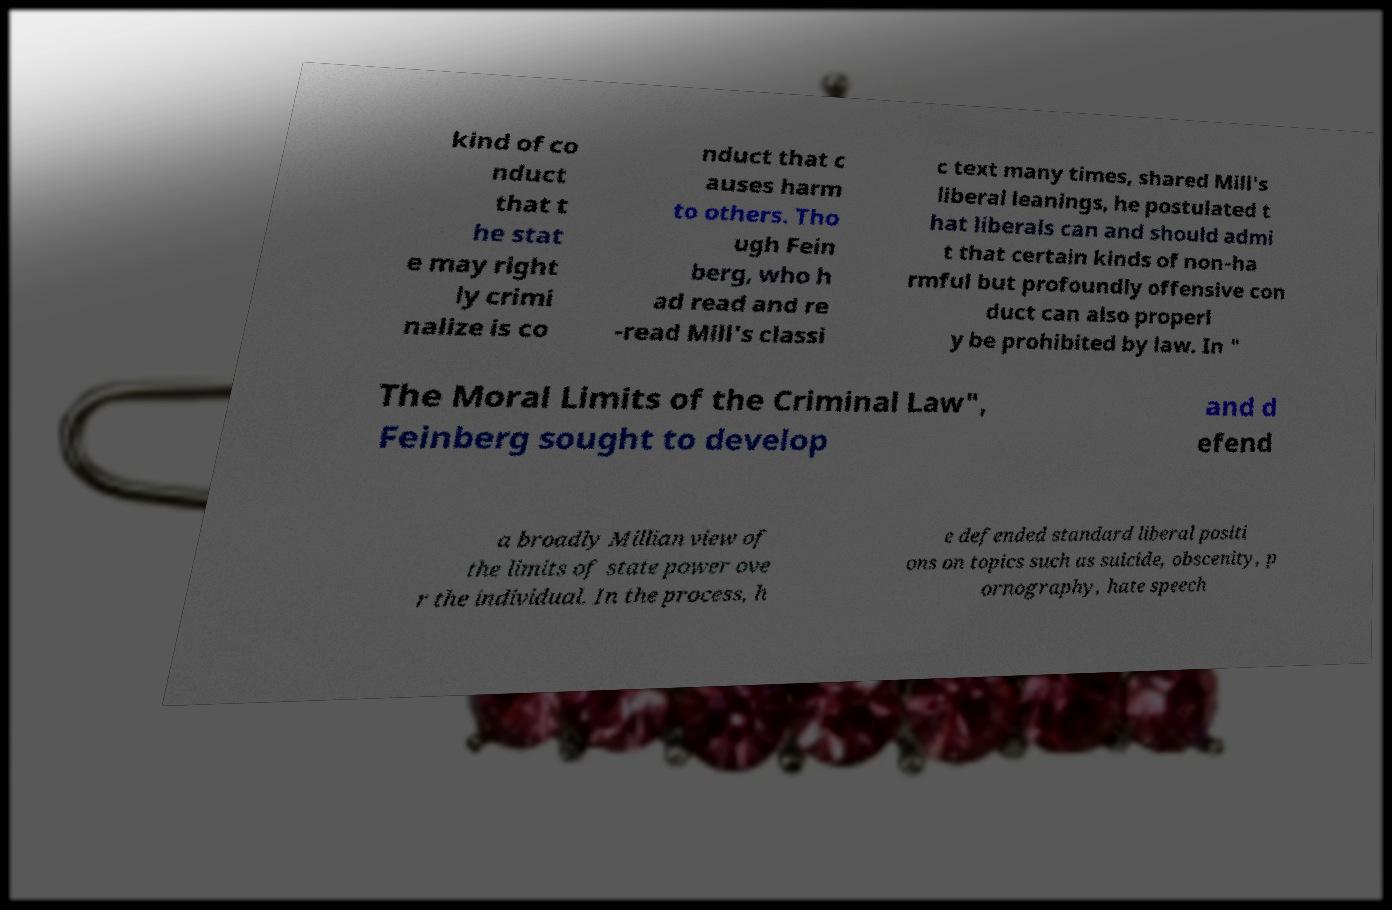Please read and relay the text visible in this image. What does it say? kind of co nduct that t he stat e may right ly crimi nalize is co nduct that c auses harm to others. Tho ugh Fein berg, who h ad read and re -read Mill's classi c text many times, shared Mill's liberal leanings, he postulated t hat liberals can and should admi t that certain kinds of non-ha rmful but profoundly offensive con duct can also properl y be prohibited by law. In " The Moral Limits of the Criminal Law", Feinberg sought to develop and d efend a broadly Millian view of the limits of state power ove r the individual. In the process, h e defended standard liberal positi ons on topics such as suicide, obscenity, p ornography, hate speech 